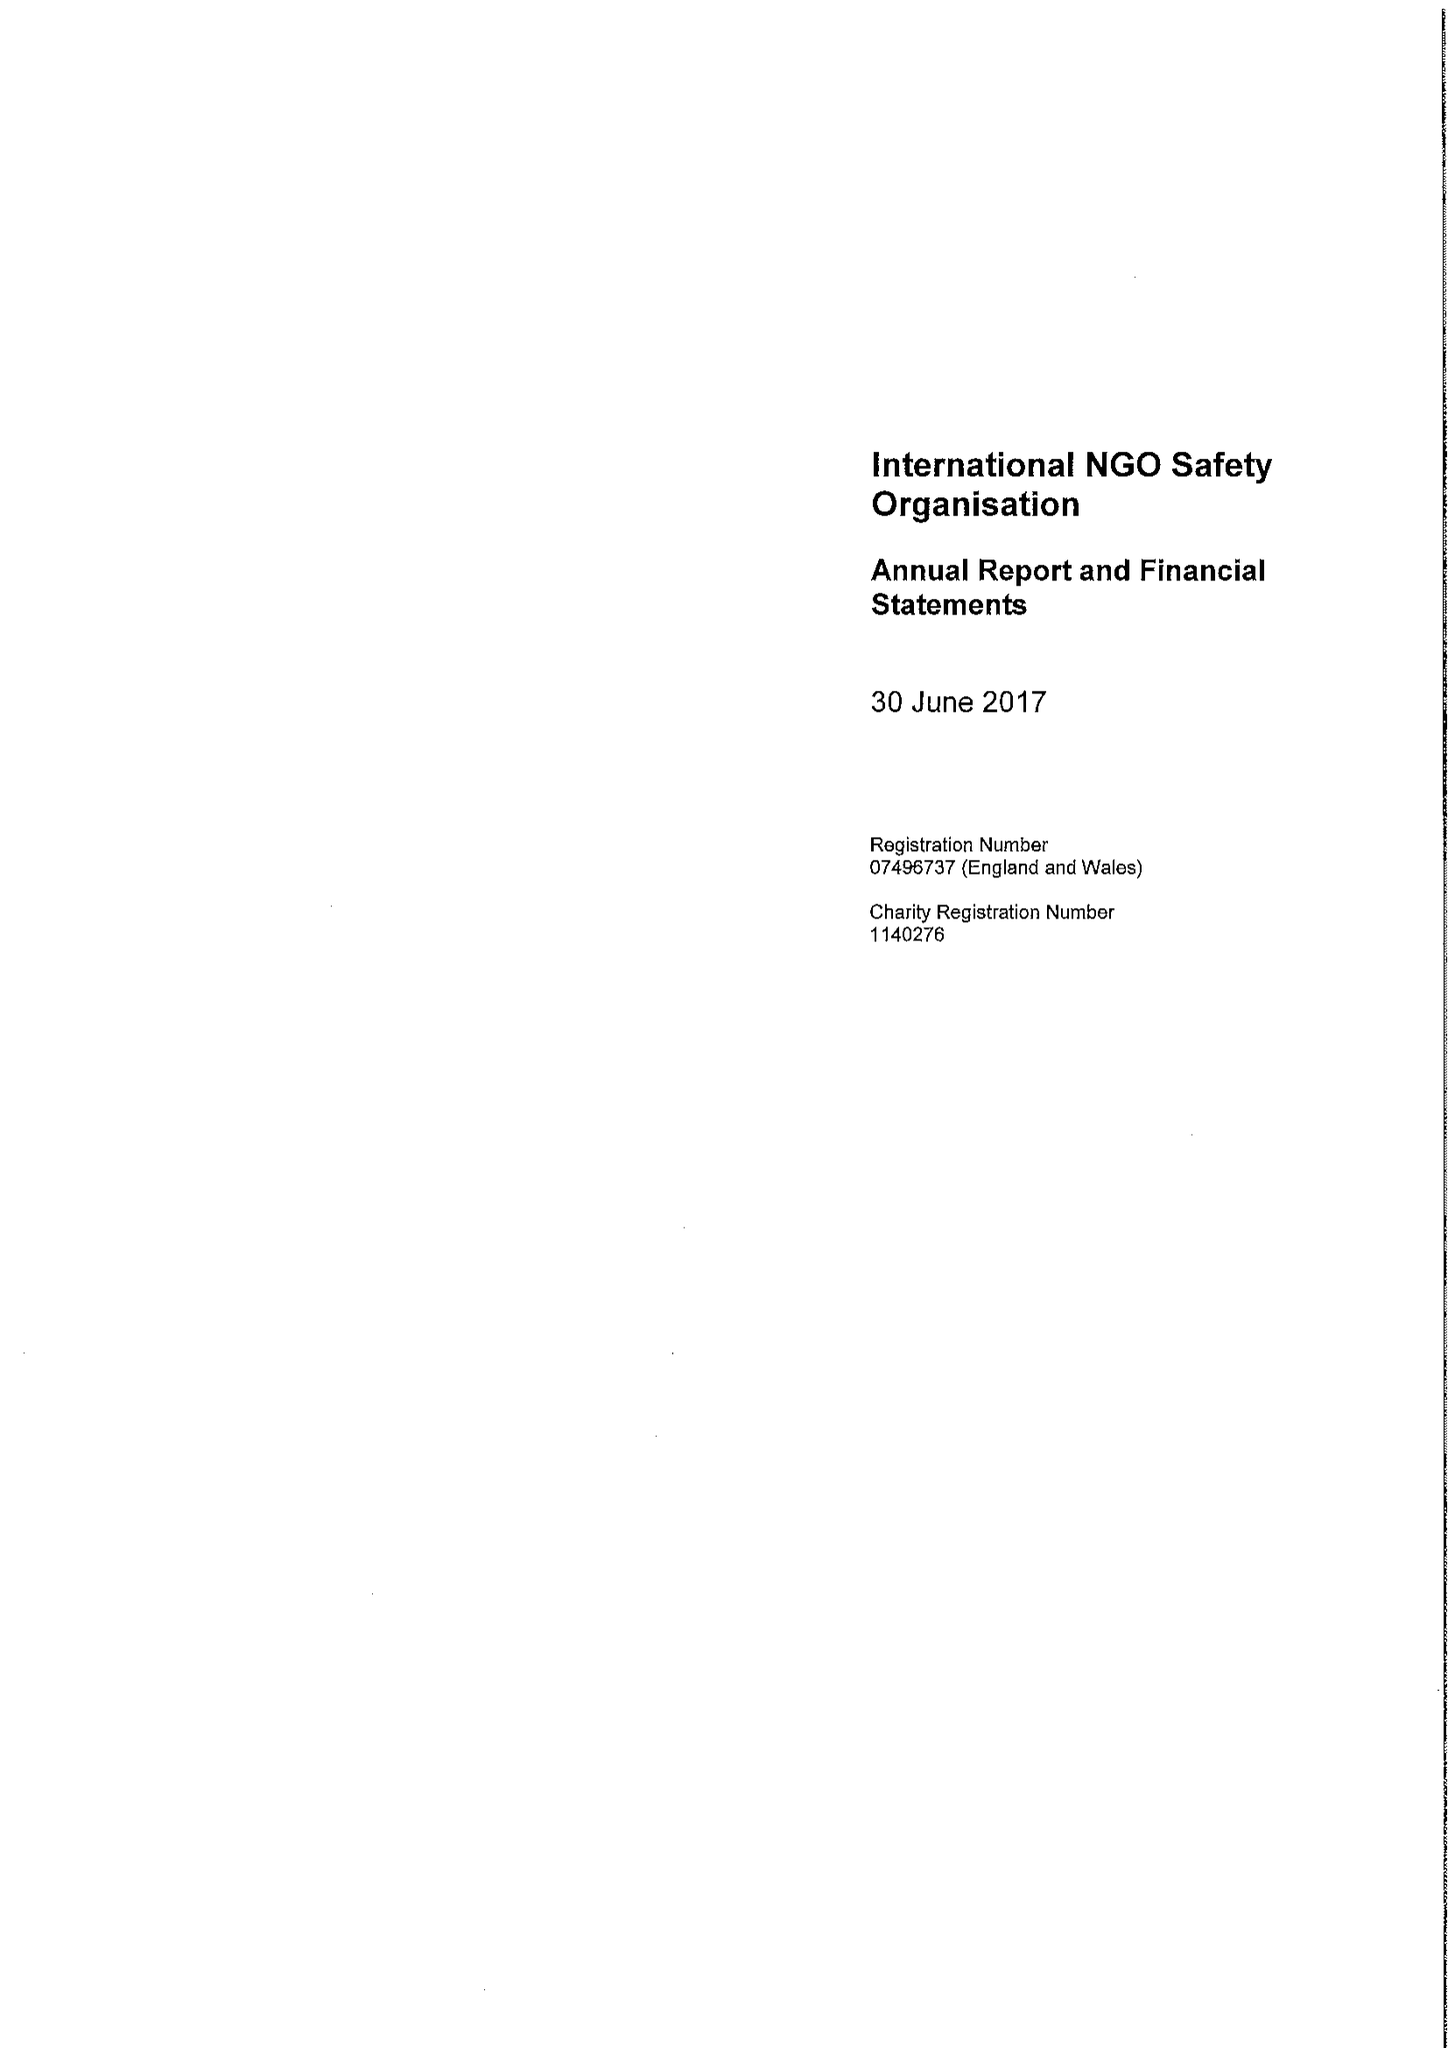What is the value for the income_annually_in_british_pounds?
Answer the question using a single word or phrase. 13519942.00 